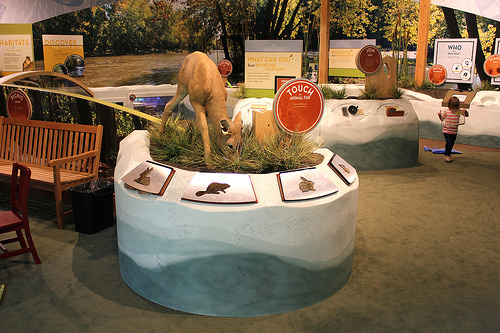<image>
Is there a plant on the ground? No. The plant is not positioned on the ground. They may be near each other, but the plant is not supported by or resting on top of the ground. 